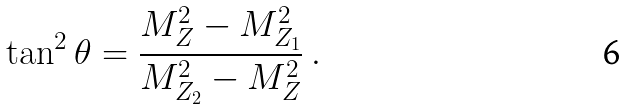<formula> <loc_0><loc_0><loc_500><loc_500>\tan ^ { 2 } \theta = \frac { M _ { Z } ^ { 2 } - M _ { Z _ { 1 } } ^ { 2 } } { M _ { Z _ { 2 } } ^ { 2 } - M _ { Z } ^ { 2 } } \ .</formula> 